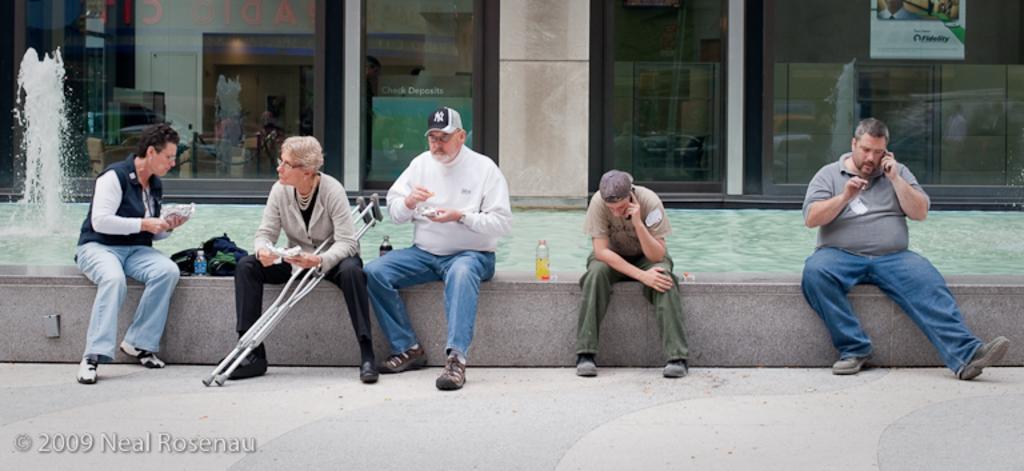Could you give a brief overview of what you see in this image? In this image I can see group of people sitting. In front the person is wearing white shirt, blue pant and the person at left is holding two sticks. Background I can see a fountain and I can also see few glass doors and the wall is in cream color. 